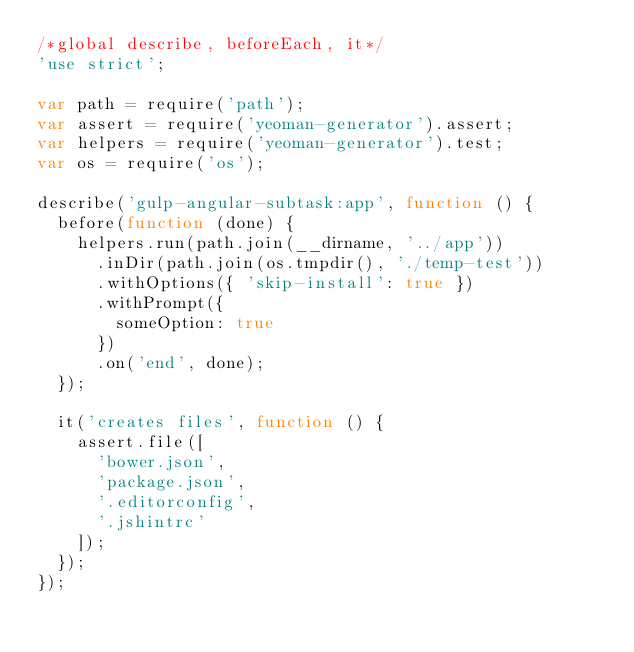<code> <loc_0><loc_0><loc_500><loc_500><_JavaScript_>/*global describe, beforeEach, it*/
'use strict';

var path = require('path');
var assert = require('yeoman-generator').assert;
var helpers = require('yeoman-generator').test;
var os = require('os');

describe('gulp-angular-subtask:app', function () {
  before(function (done) {
    helpers.run(path.join(__dirname, '../app'))
      .inDir(path.join(os.tmpdir(), './temp-test'))
      .withOptions({ 'skip-install': true })
      .withPrompt({
        someOption: true
      })
      .on('end', done);
  });

  it('creates files', function () {
    assert.file([
      'bower.json',
      'package.json',
      '.editorconfig',
      '.jshintrc'
    ]);
  });
});
</code> 